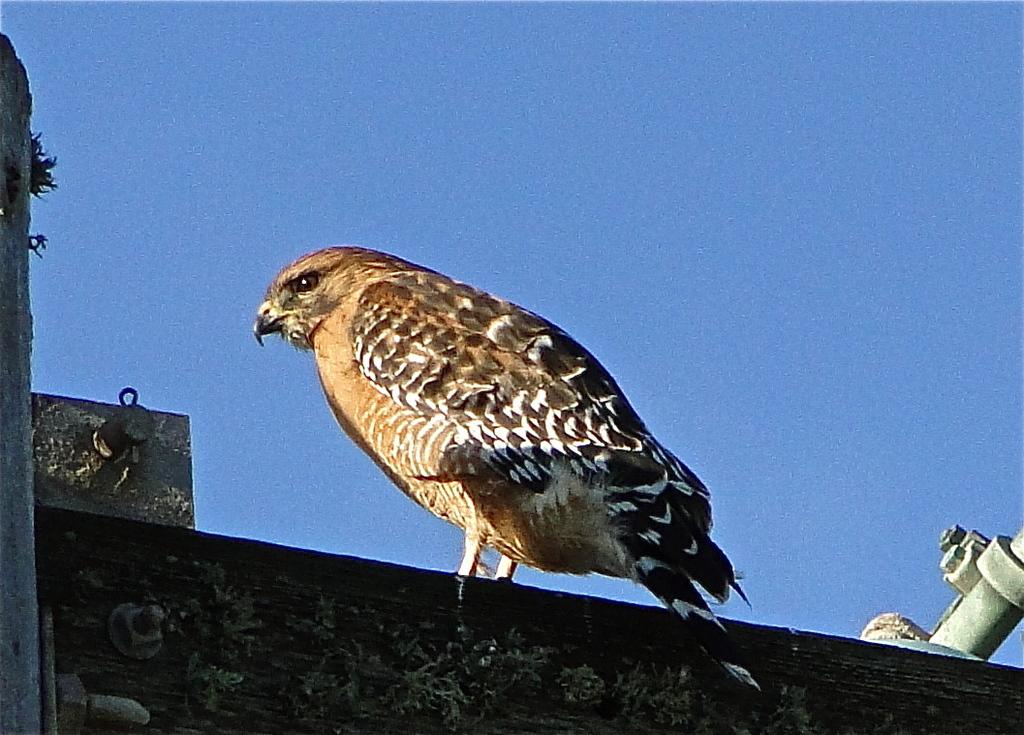Where was the image taken? The image was taken outdoors. What can be seen at the top of the image? There is a sky visible at the top of the image. What is at the bottom of the image? There is a wall at the bottom of the image. What animal is present in the image? An eagle is standing on the wall in the middle of the image. What type of wristwatch is the eagle wearing in the image? There is no wristwatch present on the eagle in the image. What type of building is visible in the background of the image? There is no building visible in the background of the image; it is taken outdoors with a sky and a wall. 